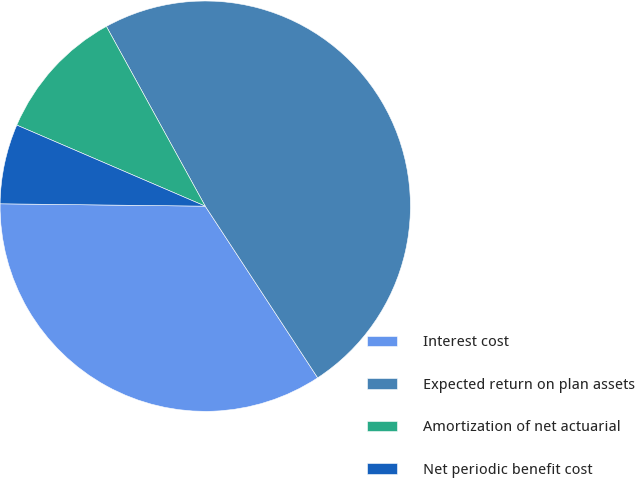Convert chart to OTSL. <chart><loc_0><loc_0><loc_500><loc_500><pie_chart><fcel>Interest cost<fcel>Expected return on plan assets<fcel>Amortization of net actuarial<fcel>Net periodic benefit cost<nl><fcel>34.41%<fcel>48.77%<fcel>10.53%<fcel>6.28%<nl></chart> 